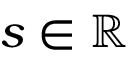Convert formula to latex. <formula><loc_0><loc_0><loc_500><loc_500>s \in \mathbb { R }</formula> 